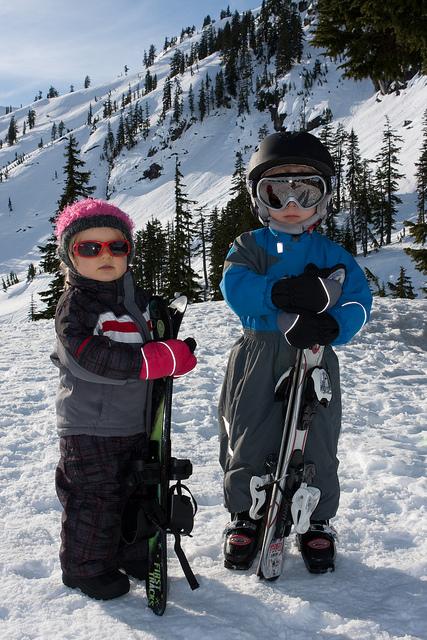What season is this?
Give a very brief answer. Winter. Can you see any eyes in this photo?
Keep it brief. No. Are these adults?
Quick response, please. No. Why do the children have goggles on that are tinted red?
Be succinct. Protection. 